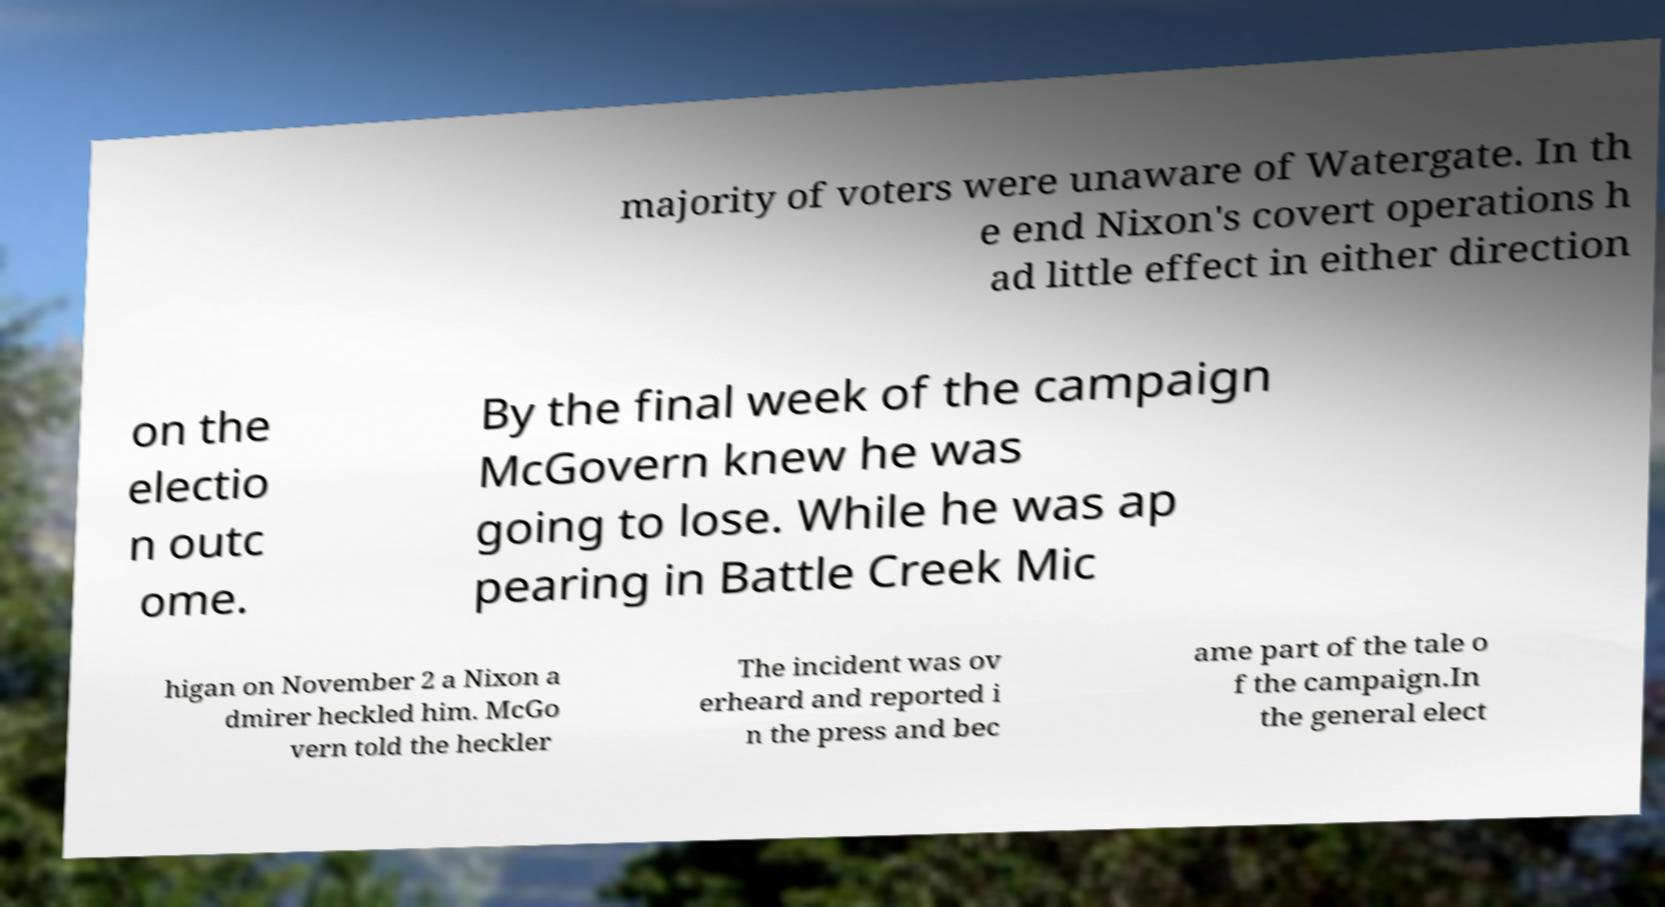Could you extract and type out the text from this image? majority of voters were unaware of Watergate. In th e end Nixon's covert operations h ad little effect in either direction on the electio n outc ome. By the final week of the campaign McGovern knew he was going to lose. While he was ap pearing in Battle Creek Mic higan on November 2 a Nixon a dmirer heckled him. McGo vern told the heckler The incident was ov erheard and reported i n the press and bec ame part of the tale o f the campaign.In the general elect 